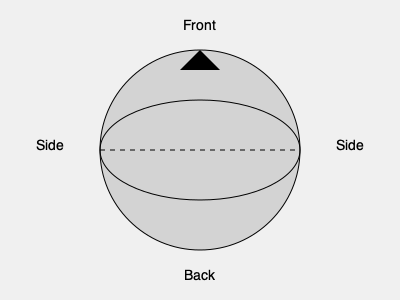As a music producer recording a drum kit, you're considering using a microphone with the polar pattern shown in the diagram. Which part of the drum kit would be most suitable to capture with this microphone, and how should it be positioned for optimal sound pickup? To answer this question, let's analyze the polar pattern and consider the characteristics of different drum kit components:

1. The polar pattern shown is cardioid, which is more sensitive to sound from the front and less sensitive to sound from the sides and rear.

2. Drum kit components:
   a) Kick drum: Requires focused pickup, often with a large-diaphragm dynamic mic
   b) Snare drum: Needs precise capture, usually with a cardioid dynamic mic
   c) Toms: Benefit from focused pickup, often using cardioid dynamic mics
   d) Overheads: Capture cymbals and overall kit sound, typically using condenser mics

3. The cardioid pattern is ideal for capturing individual drums while rejecting off-axis sounds from other kit pieces.

4. The snare drum is a central element in most drum patterns and requires precise capture while minimizing bleed from hi-hats and other nearby drums.

5. Optimal placement for a cardioid mic on the snare:
   a) Position the mic 1-3 inches above the drum head
   b) Angle the mic towards the center of the drum head
   c) Point the null (rear) of the mic towards the hi-hat to minimize bleed

6. This placement takes advantage of the cardioid pattern's front sensitivity to capture the snare's attack and body while using its rear rejection to minimize unwanted sounds.
Answer: Snare drum; positioned 1-3 inches above, angled towards center, rear facing hi-hat 